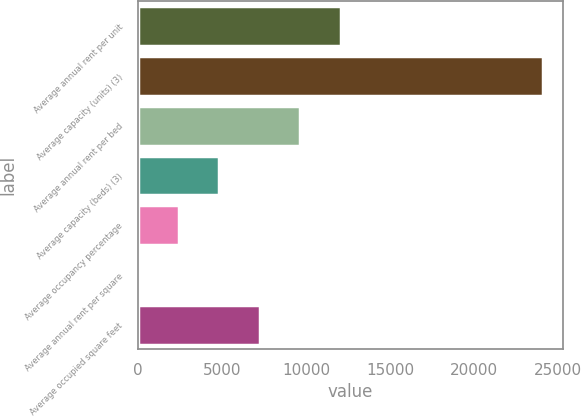Convert chart to OTSL. <chart><loc_0><loc_0><loc_500><loc_500><bar_chart><fcel>Average annual rent per unit<fcel>Average capacity (units) (3)<fcel>Average annual rent per bed<fcel>Average capacity (beds) (3)<fcel>Average occupancy percentage<fcel>Average annual rent per square<fcel>Average occupied square feet<nl><fcel>12077.5<fcel>24112<fcel>9670.6<fcel>4856.8<fcel>2449.9<fcel>43<fcel>7263.7<nl></chart> 